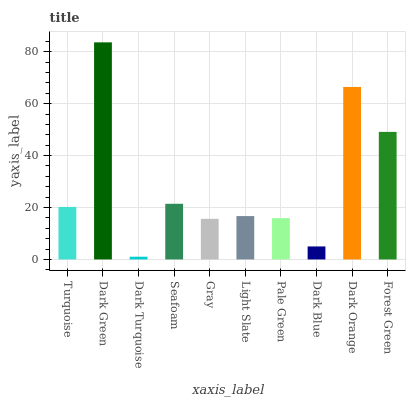Is Dark Turquoise the minimum?
Answer yes or no. Yes. Is Dark Green the maximum?
Answer yes or no. Yes. Is Dark Green the minimum?
Answer yes or no. No. Is Dark Turquoise the maximum?
Answer yes or no. No. Is Dark Green greater than Dark Turquoise?
Answer yes or no. Yes. Is Dark Turquoise less than Dark Green?
Answer yes or no. Yes. Is Dark Turquoise greater than Dark Green?
Answer yes or no. No. Is Dark Green less than Dark Turquoise?
Answer yes or no. No. Is Turquoise the high median?
Answer yes or no. Yes. Is Light Slate the low median?
Answer yes or no. Yes. Is Forest Green the high median?
Answer yes or no. No. Is Dark Orange the low median?
Answer yes or no. No. 